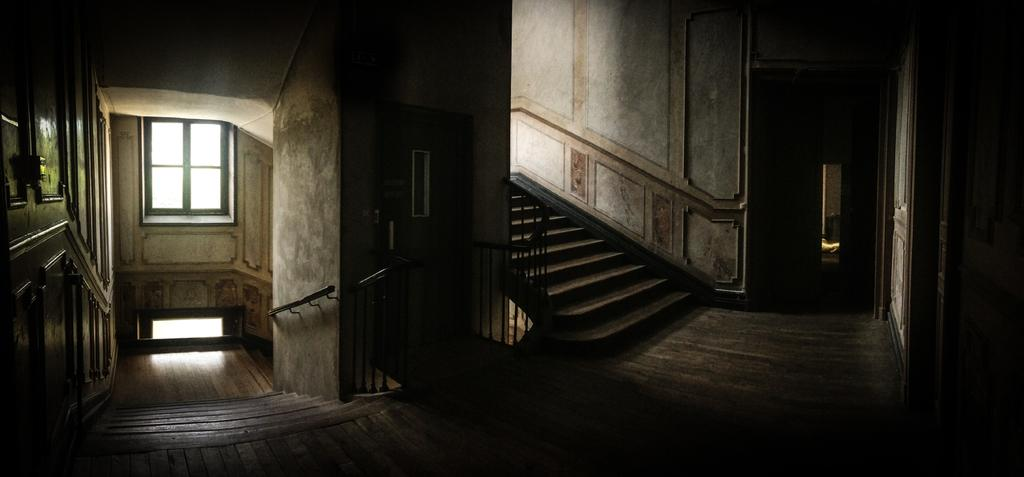Where was the image taken? The image was taken inside a building. What architectural features can be seen in the image? There are staircases, railings, walls, and a window visible in the image. What type of flooring is present at the bottom of the image? There is wooden flooring at the bottom of the image. What type of plane is flying outside the window in the image? There is no plane visible outside the window in the image. Can you tell me how many soldiers are present in the image? There are no soldiers or army-related elements present in the image. 